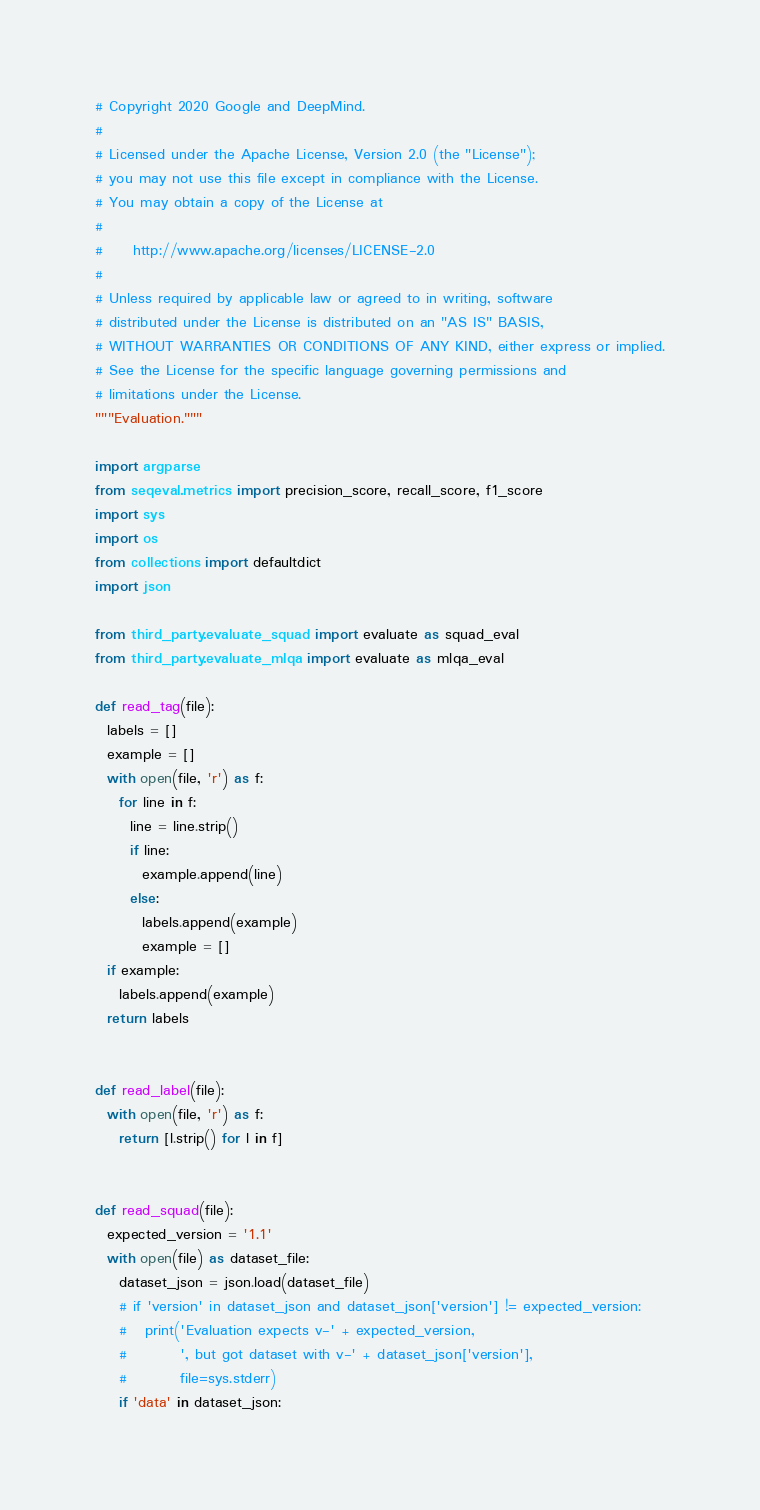Convert code to text. <code><loc_0><loc_0><loc_500><loc_500><_Python_># Copyright 2020 Google and DeepMind.
#
# Licensed under the Apache License, Version 2.0 (the "License");
# you may not use this file except in compliance with the License.
# You may obtain a copy of the License at
#
#     http://www.apache.org/licenses/LICENSE-2.0
#
# Unless required by applicable law or agreed to in writing, software
# distributed under the License is distributed on an "AS IS" BASIS,
# WITHOUT WARRANTIES OR CONDITIONS OF ANY KIND, either express or implied.
# See the License for the specific language governing permissions and
# limitations under the License.
"""Evaluation."""

import argparse
from seqeval.metrics import precision_score, recall_score, f1_score
import sys
import os
from collections import defaultdict
import json

from third_party.evaluate_squad import evaluate as squad_eval
from third_party.evaluate_mlqa import evaluate as mlqa_eval

def read_tag(file):
  labels = []
  example = []
  with open(file, 'r') as f:
    for line in f:
      line = line.strip()
      if line:
        example.append(line)
      else:
        labels.append(example)
        example = []
  if example:
    labels.append(example)
  return labels


def read_label(file):
  with open(file, 'r') as f:
    return [l.strip() for l in f]


def read_squad(file):
  expected_version = '1.1'
  with open(file) as dataset_file:
    dataset_json = json.load(dataset_file)
    # if 'version' in dataset_json and dataset_json['version'] != expected_version:
    #   print('Evaluation expects v-' + expected_version,
    #         ', but got dataset with v-' + dataset_json['version'],
    #         file=sys.stderr)
    if 'data' in dataset_json:</code> 